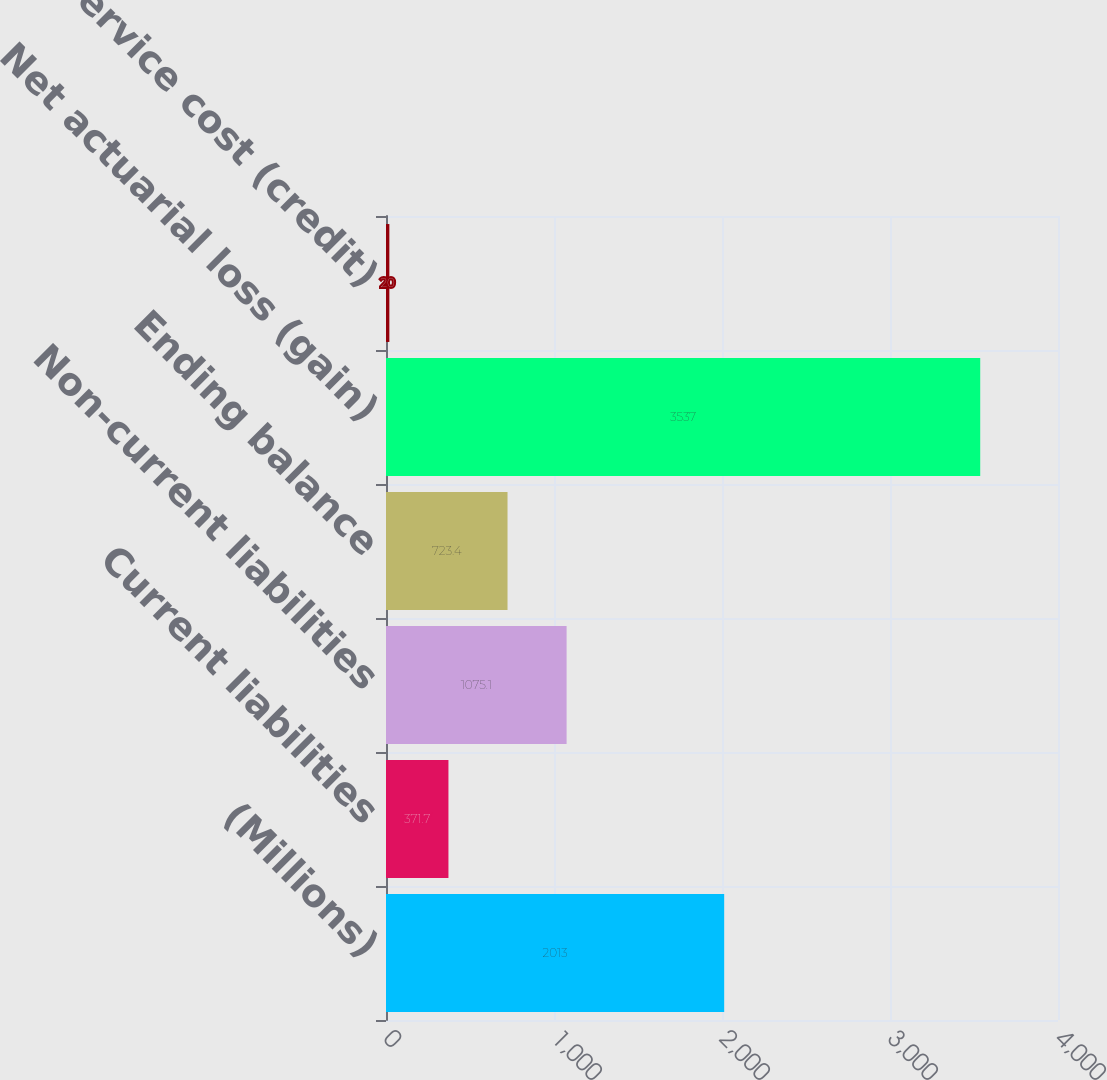Convert chart to OTSL. <chart><loc_0><loc_0><loc_500><loc_500><bar_chart><fcel>(Millions)<fcel>Current liabilities<fcel>Non-current liabilities<fcel>Ending balance<fcel>Net actuarial loss (gain)<fcel>Prior service cost (credit)<nl><fcel>2013<fcel>371.7<fcel>1075.1<fcel>723.4<fcel>3537<fcel>20<nl></chart> 